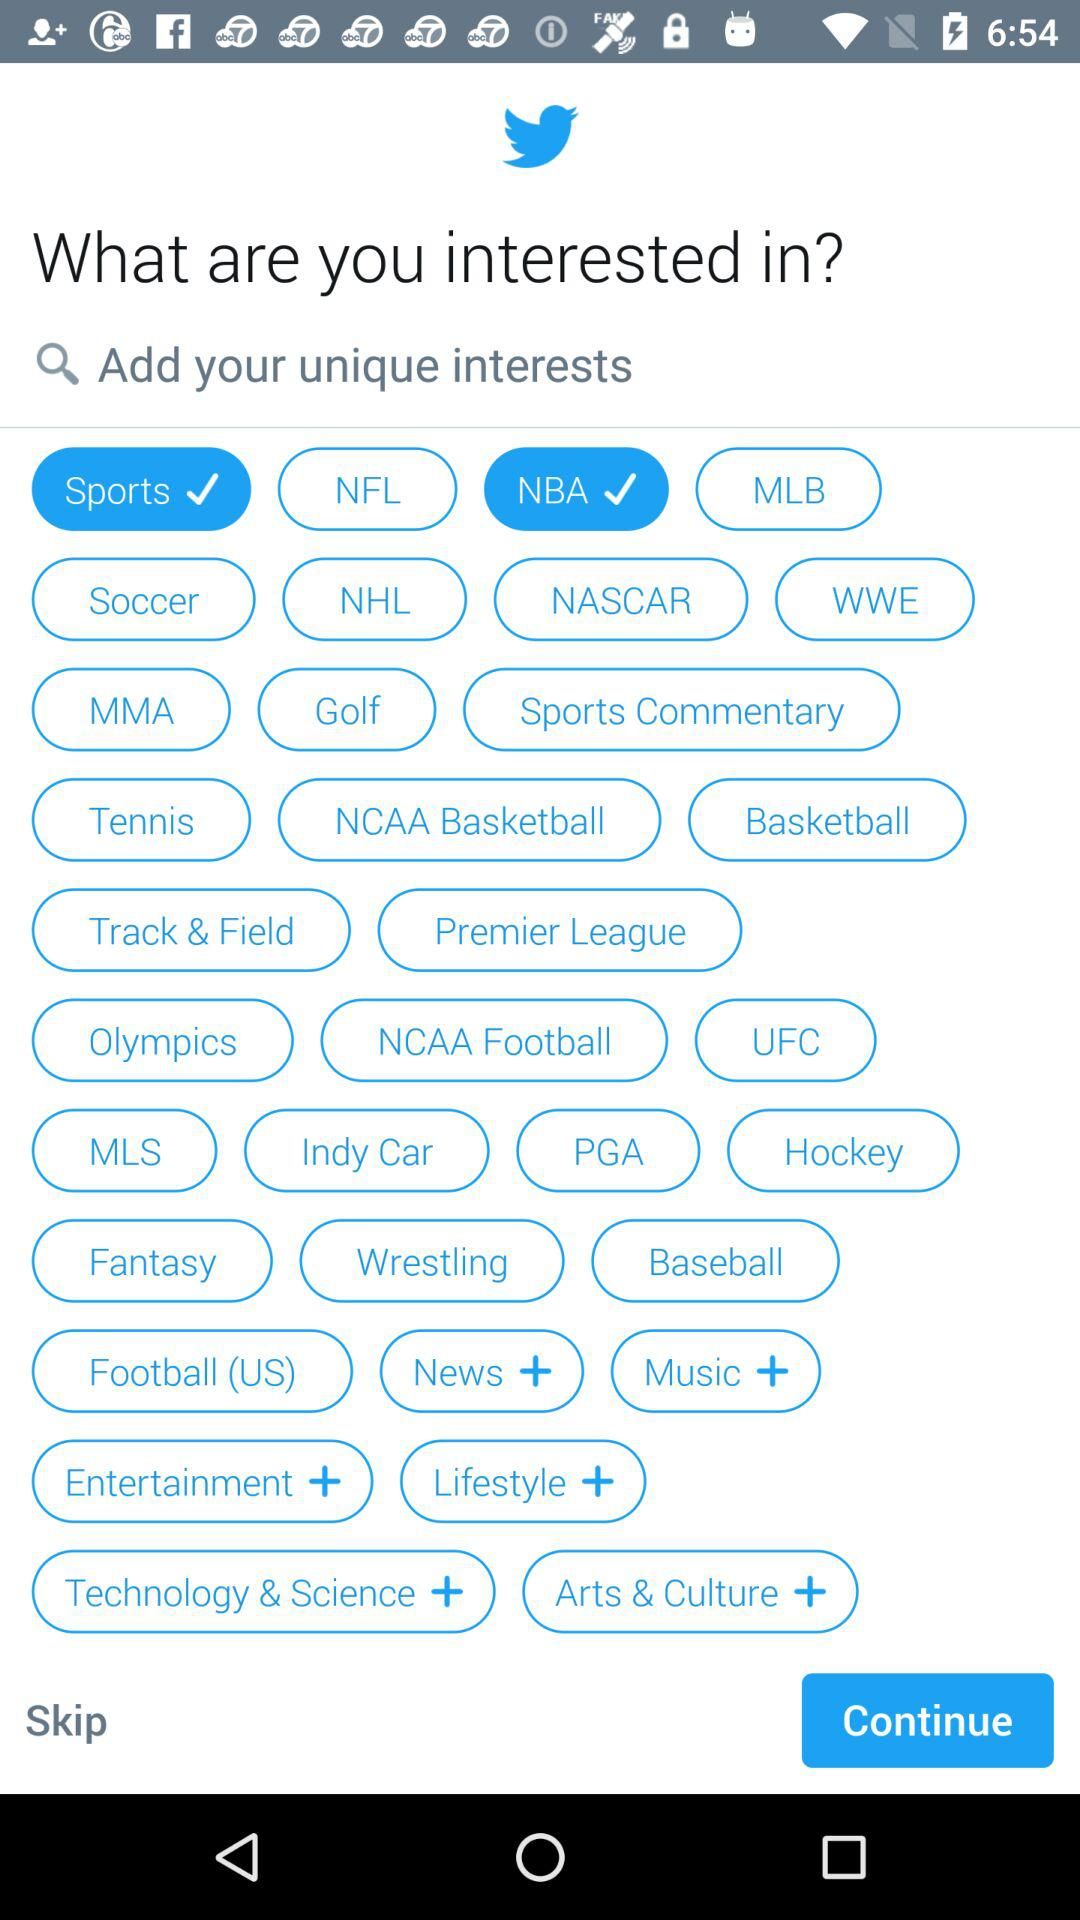What are the selected interests? The selected interests are "Sports" and "NBA". 